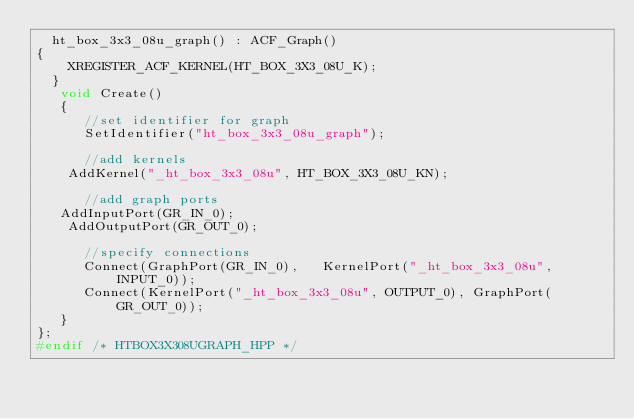<code> <loc_0><loc_0><loc_500><loc_500><_C++_>  ht_box_3x3_08u_graph() : ACF_Graph()
{
    XREGISTER_ACF_KERNEL(HT_BOX_3X3_08U_K);
  }
   void Create()
   {
      //set identifier for graph
      SetIdentifier("ht_box_3x3_08u_graph");
      
      //add kernels
    AddKernel("_ht_box_3x3_08u", HT_BOX_3X3_08U_KN);

      //add graph ports
   AddInputPort(GR_IN_0);
    AddOutputPort(GR_OUT_0);

      //specify connections
      Connect(GraphPort(GR_IN_0),   KernelPort("_ht_box_3x3_08u", INPUT_0));
      Connect(KernelPort("_ht_box_3x3_08u", OUTPUT_0), GraphPort(GR_OUT_0));
   }
};
#endif /* HTBOX3X308UGRAPH_HPP */</code> 